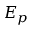<formula> <loc_0><loc_0><loc_500><loc_500>E _ { p }</formula> 